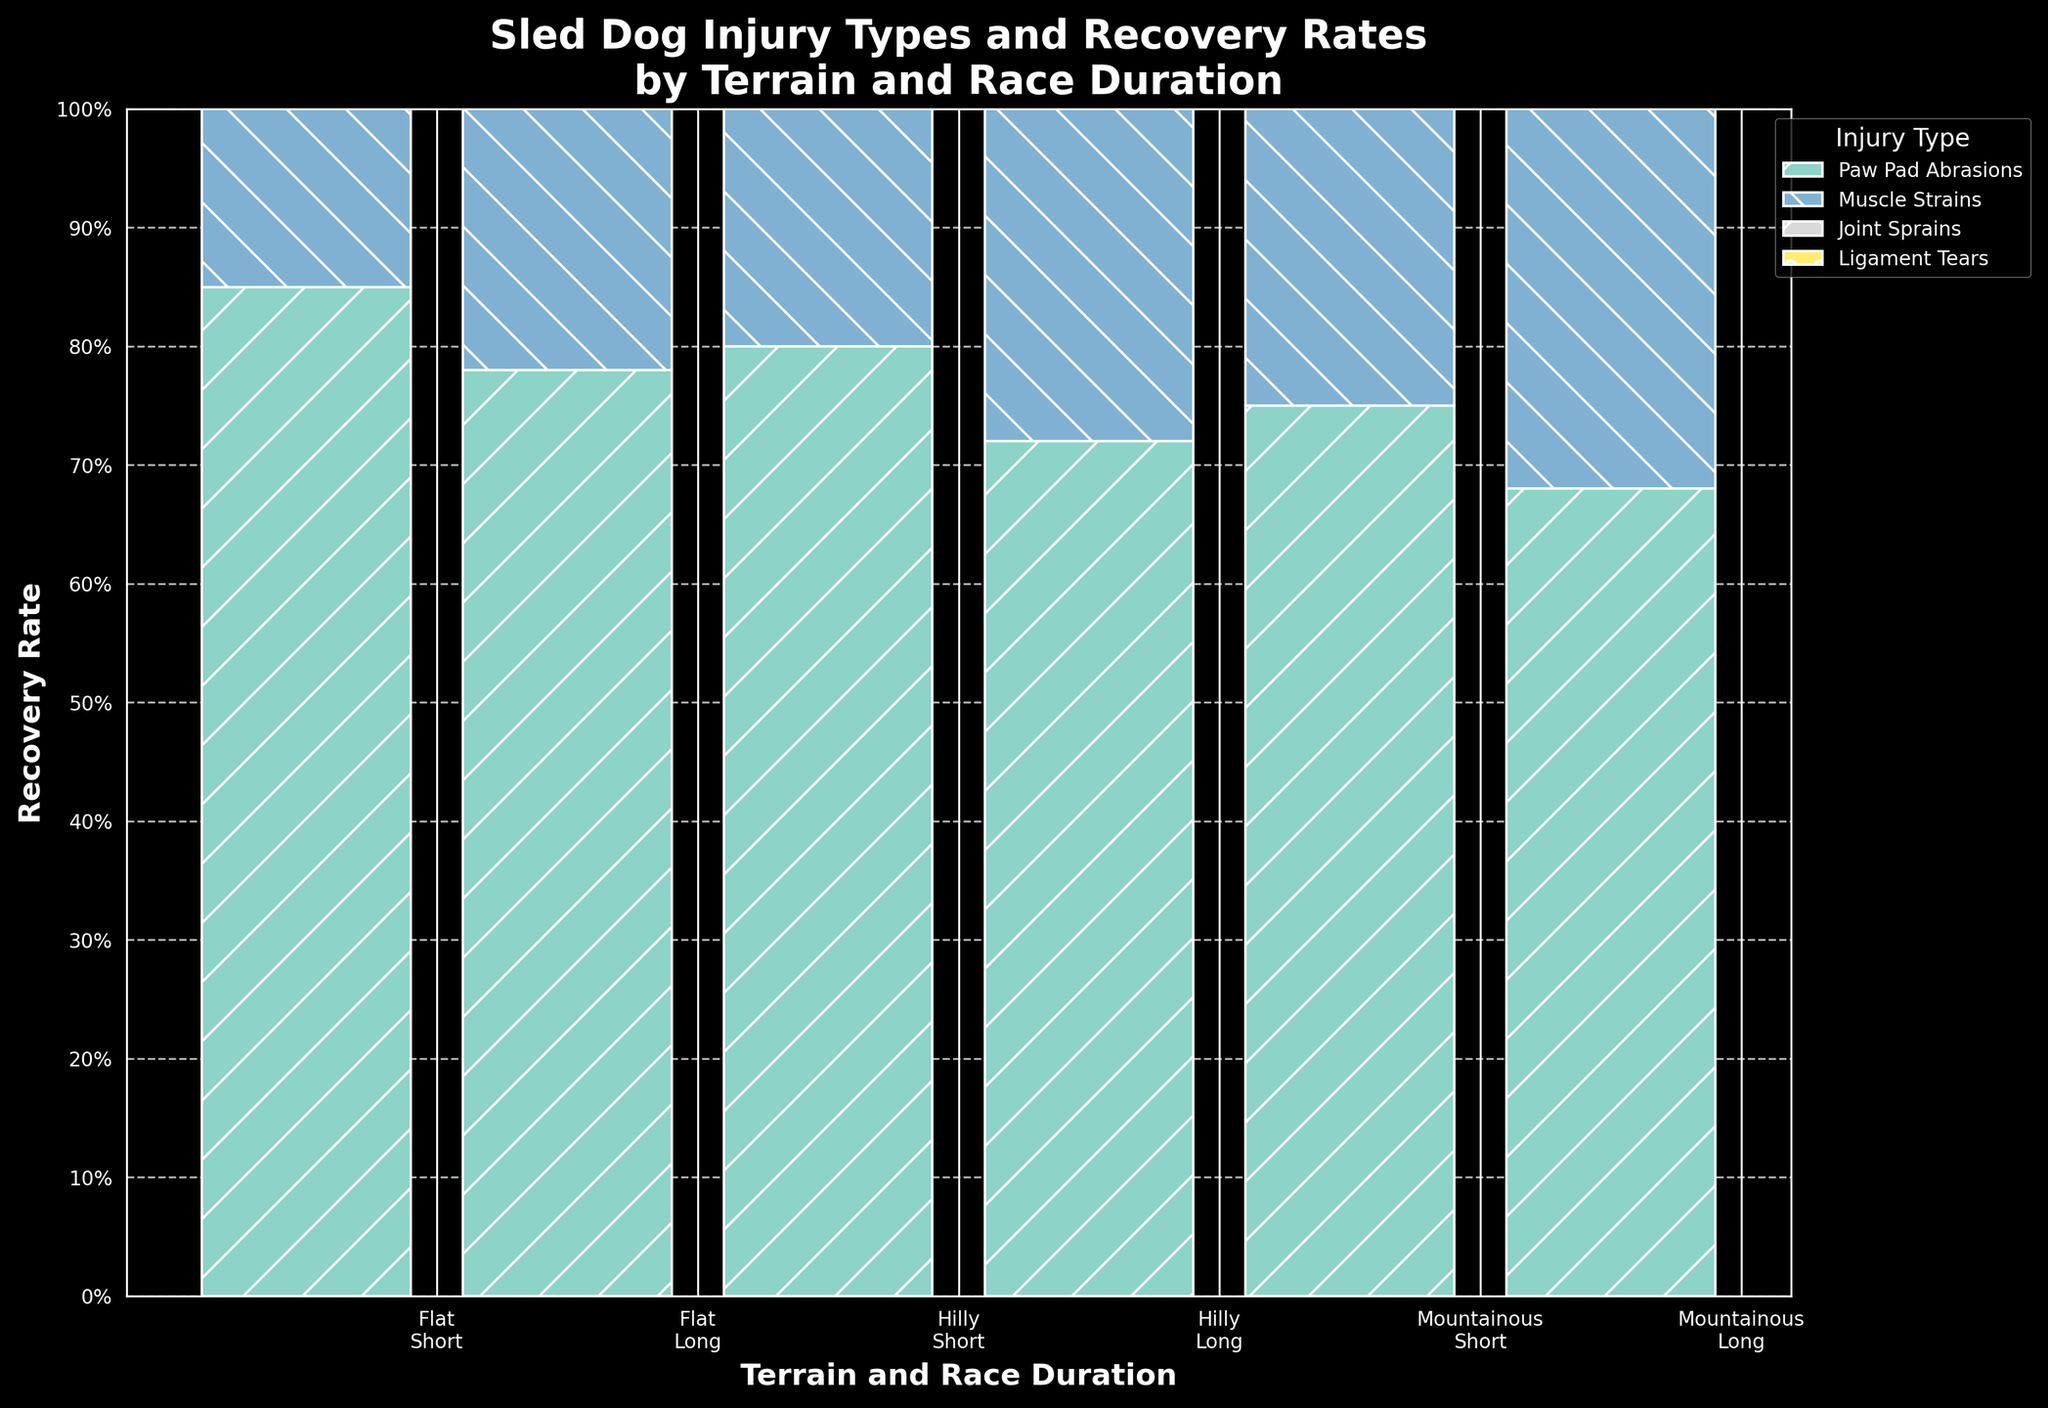What is the title of the figure? The title of the figure is usually displayed at the top of the plot. Here it is "Sled Dog Injury Types and Recovery Rates by Terrain and Race Duration".
Answer: Sled Dog Injury Types and Recovery Rates by Terrain and Race Duration Which recovery rate is the highest in flat terrain with a long race duration? By examining the bars for "Flat" terrain and "Long" race duration, we note the heights of the segments. "Muscle Strains" stands out as the highest at 88%.
Answer: 88% How do recovery rates for paw pad abrasions compare between flat and mountainous terrains for long races? Compare the height of the segments representing "Paw Pad Abrasions" in the bars for "Flat" and "Mountainous" terrains and "Long" race duration. The recovery rate for "Flat" is 78%, and for "Mountainous" is 68%. The rate is higher in the flat terrain.
Answer: Flat is 78%, Mountainous is 68% Which injury type shows the lowest recovery rate in mountainous terrain during long races? In the bar for "Mountainous" with "Long" race duration, the shortest segment indicates "Ligament Tears" with a recovery rate of 65%.
Answer: Ligament Tears What is the average recovery rate for muscle strains across all terrains and race durations? Summing up the recovery rates for Muscle Strains across all combinations: 92%, 88%, 89%, 83%, 86%, 79%. Their total is 92 + 88 + 89 + 83 + 86 + 79 = 517. Dividing by the six occurrences gives an average recovery rate of 517/6 ≈ 86.2%.
Answer: ≈ 86.2% How do recovery rates for short races compare between flat and hilly terrains for muscle strains? For "Short" races, the segments representing "Muscle Strains" in "Flat" and "Hilly" terrains indicate heights of 92% and 89%, respectively. Comparing these two values, the flat terrain has a slightly higher rate.
Answer: Flat is 92%, Hilly is 89% Which terrain and race duration combination has the highest overall recovery rate? Adding the heights of all segments for each combination, the highest total segment height will represent the highest overall recovery rate combination. "Flat" terrain with "Short" race duration has the highest recovery rates summed up.
Answer: Flat, Short What percentage difference is there in recovery rates for paw pad abrasions between the flat and hilly terrains during long races? The recovery rate for "Paw Pad Abrasions" is 78% in "Flat" terrain and 72% in "Hilly" terrain for "Long" races. The percentage difference is (78% - 72%) = 6%.
Answer: 6% Compare the recovery rates for joint sprains in short races across the three terrain types. For "Joint Sprains" in "Short" races, inspect the respective segment heights: "Flat" and "Short" has none, "Hilly" and "Short" has 85%, "Mountainous" and "Short" has 80%.
Answer: Flat (N/A), Hilly 85%, Mountainous 80% 